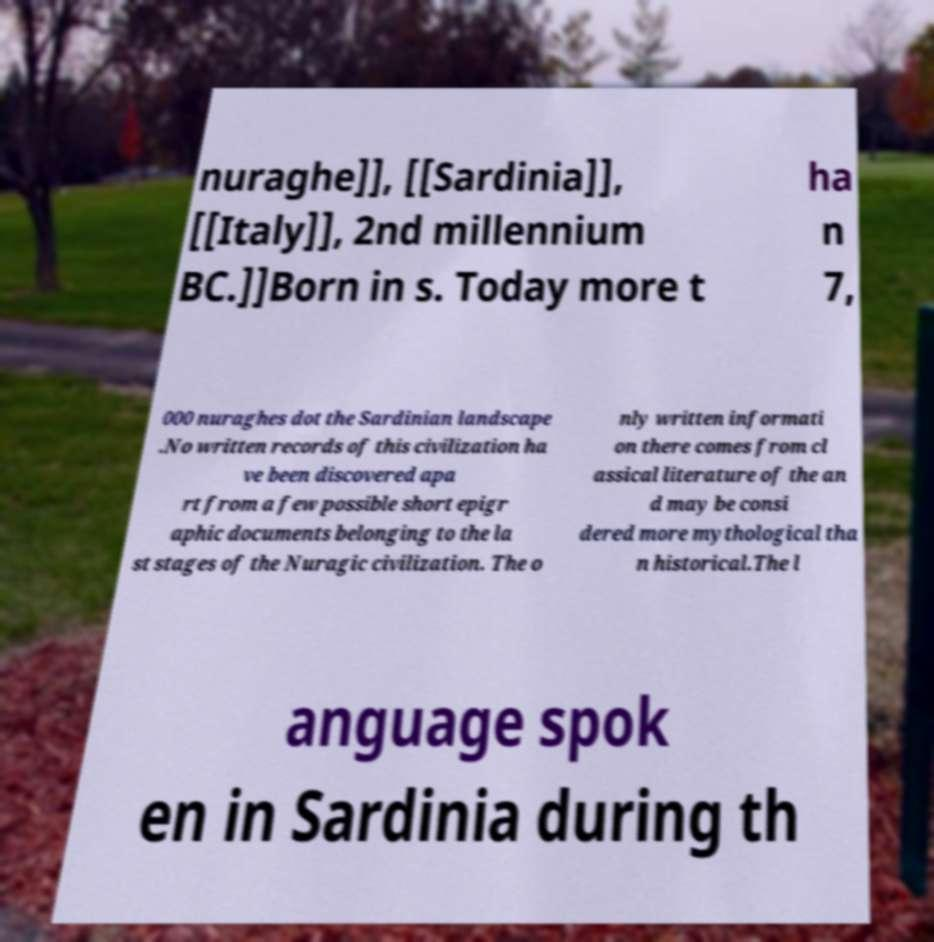Please identify and transcribe the text found in this image. nuraghe]], [[Sardinia]], [[Italy]], 2nd millennium BC.]]Born in s. Today more t ha n 7, 000 nuraghes dot the Sardinian landscape .No written records of this civilization ha ve been discovered apa rt from a few possible short epigr aphic documents belonging to the la st stages of the Nuragic civilization. The o nly written informati on there comes from cl assical literature of the an d may be consi dered more mythological tha n historical.The l anguage spok en in Sardinia during th 